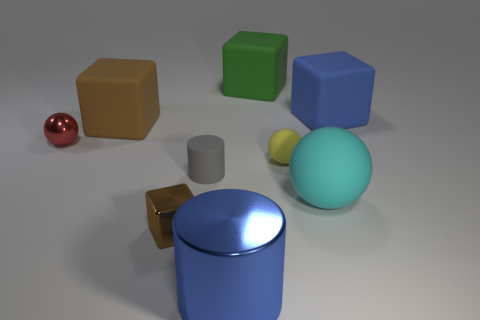How many brown blocks must be subtracted to get 1 brown blocks? 1 Subtract 3 blocks. How many blocks are left? 1 Add 1 small brown things. How many objects exist? 10 Subtract all gray cylinders. How many cylinders are left? 1 Subtract all tiny spheres. How many spheres are left? 1 Subtract 0 yellow blocks. How many objects are left? 9 Subtract all cylinders. How many objects are left? 7 Subtract all gray cubes. Subtract all green spheres. How many cubes are left? 4 Subtract all gray cylinders. How many blue balls are left? 0 Subtract all yellow things. Subtract all matte things. How many objects are left? 2 